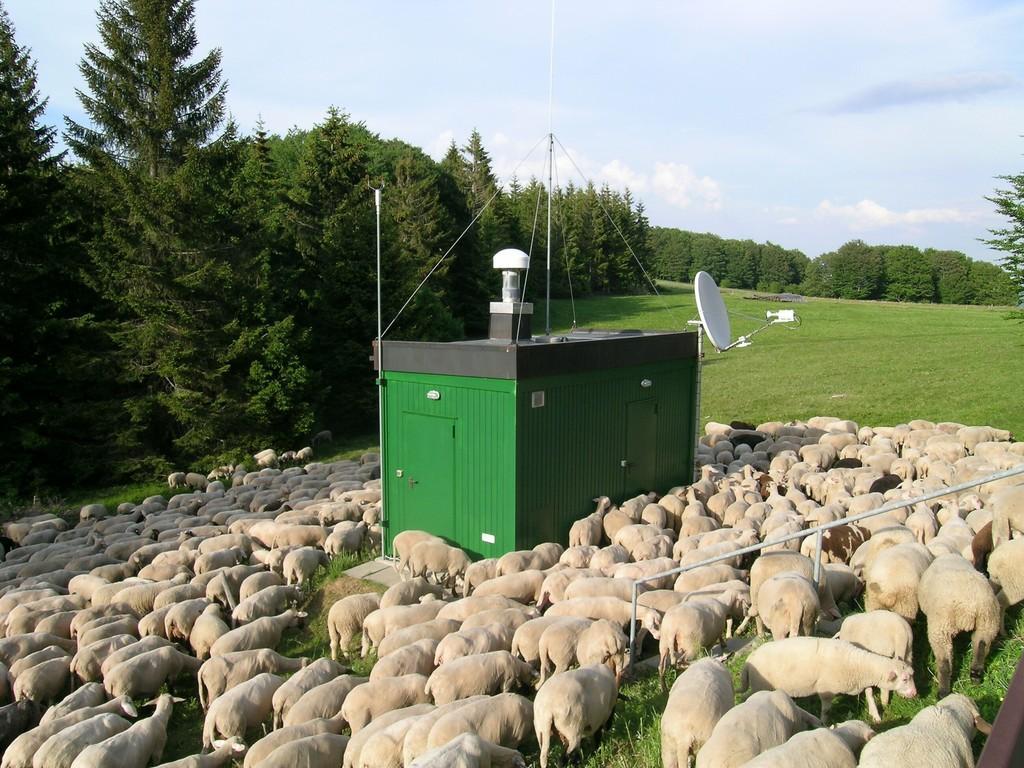How would you summarize this image in a sentence or two? In this image I can see a box like device in the center of the image with an antenna. I can see sheep on the ground. I can see trees in the center of the image behind the box. At the top of the image I can see the sky. 